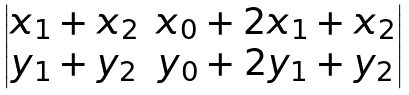<formula> <loc_0><loc_0><loc_500><loc_500>\begin{vmatrix} x _ { 1 } + x _ { 2 } & x _ { 0 } + 2 x _ { 1 } + x _ { 2 } \\ y _ { 1 } + y _ { 2 } & y _ { 0 } + 2 y _ { 1 } + y _ { 2 } \end{vmatrix}</formula> 